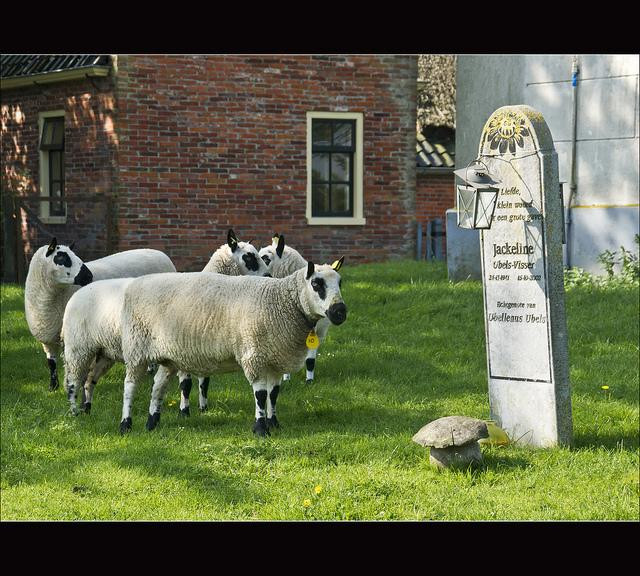What is around the animal in the foreground's neck? Please explain your reasoning. tag. The animal in the foreground has a yellow tag around its neck for identifcation. 